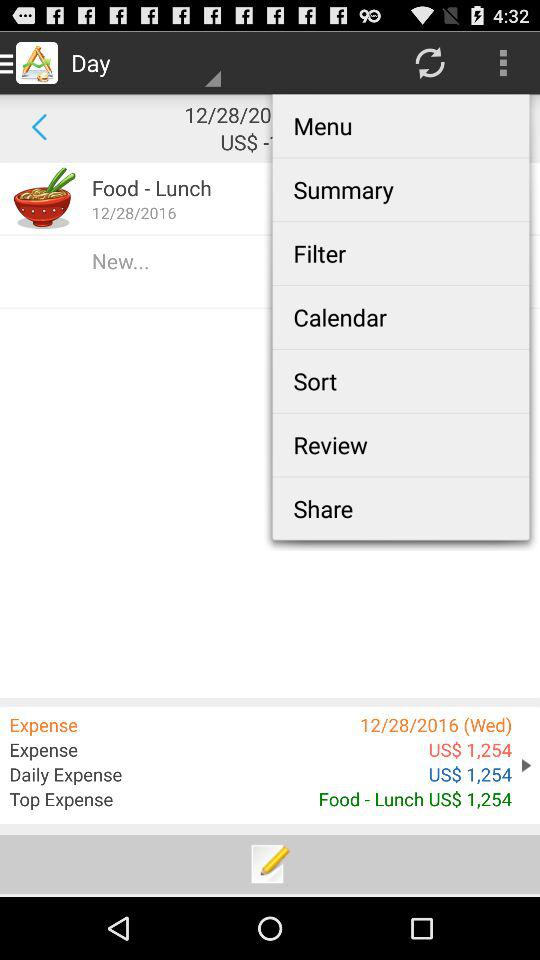What is the name of the expense on December 28th, 2016?
Answer the question using a single word or phrase. Food - Lunch 